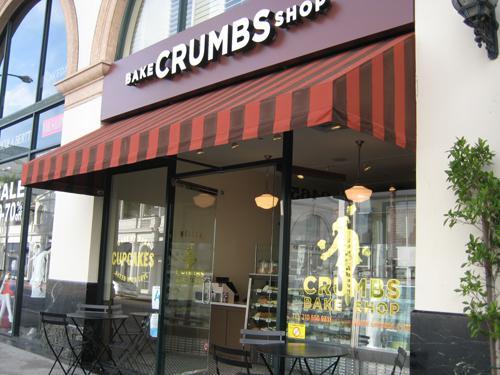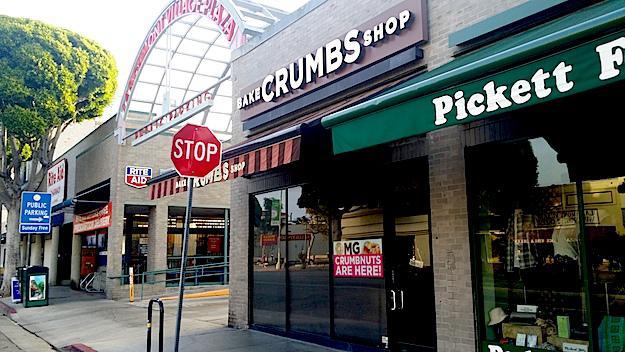The first image is the image on the left, the second image is the image on the right. For the images shown, is this caption "A red and black awning hangs over the entrance in the image on the left." true? Answer yes or no. Yes. 